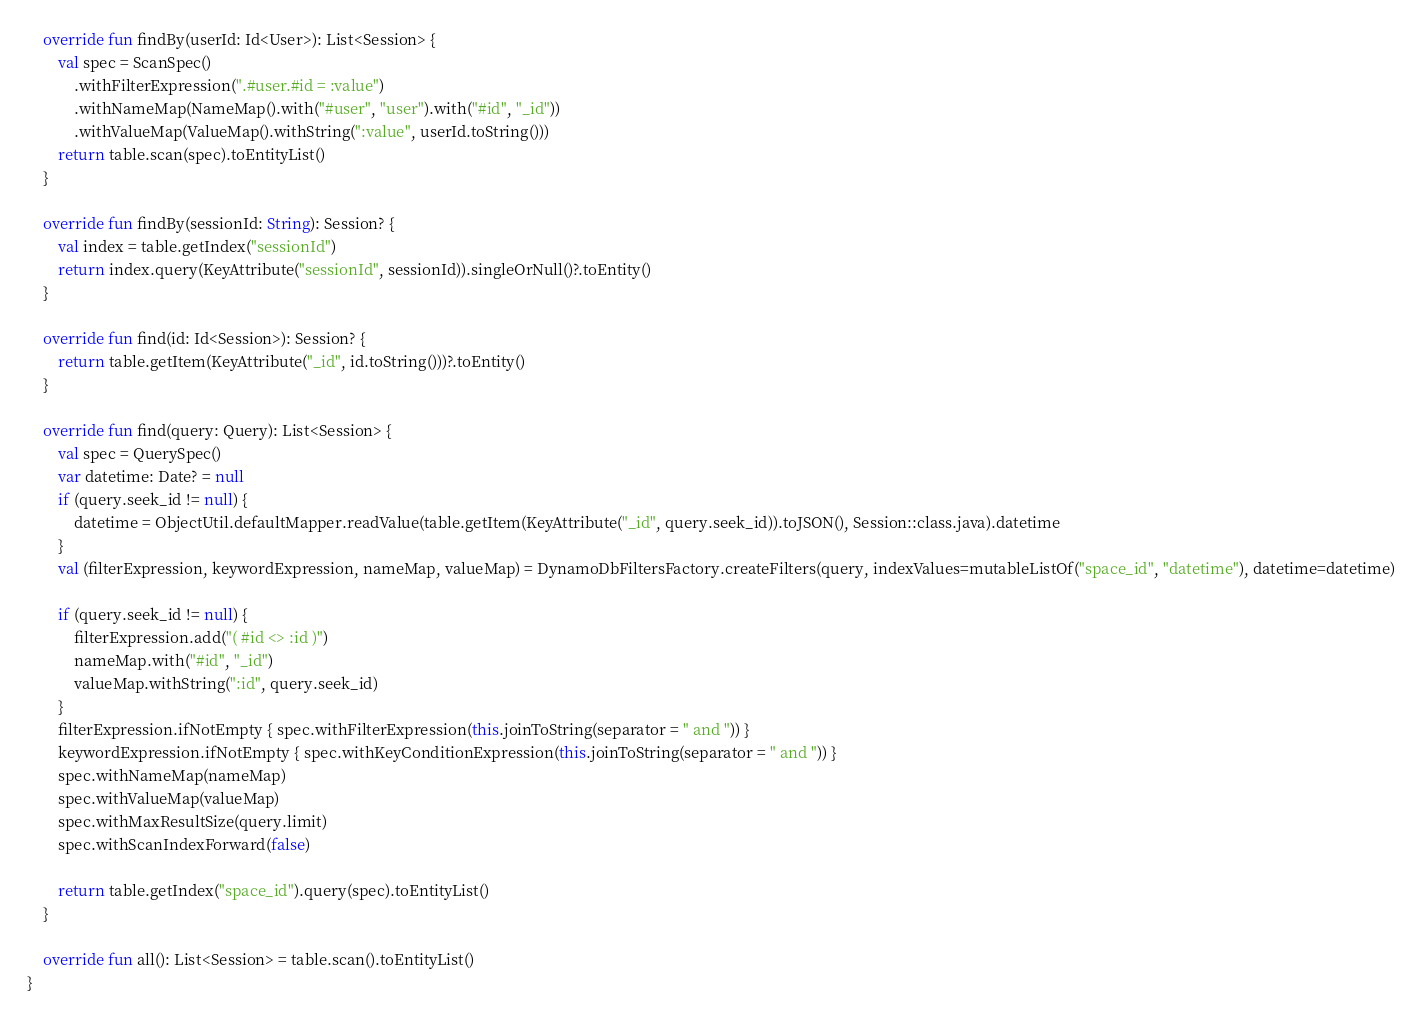Convert code to text. <code><loc_0><loc_0><loc_500><loc_500><_Kotlin_>
    override fun findBy(userId: Id<User>): List<Session> {
        val spec = ScanSpec()
            .withFilterExpression(".#user.#id = :value")
            .withNameMap(NameMap().with("#user", "user").with("#id", "_id"))
            .withValueMap(ValueMap().withString(":value", userId.toString()))
        return table.scan(spec).toEntityList()
    }

    override fun findBy(sessionId: String): Session? {
        val index = table.getIndex("sessionId")
        return index.query(KeyAttribute("sessionId", sessionId)).singleOrNull()?.toEntity()
    }

    override fun find(id: Id<Session>): Session? {
        return table.getItem(KeyAttribute("_id", id.toString()))?.toEntity()
    }

    override fun find(query: Query): List<Session> {
        val spec = QuerySpec()
        var datetime: Date? = null
        if (query.seek_id != null) {
            datetime = ObjectUtil.defaultMapper.readValue(table.getItem(KeyAttribute("_id", query.seek_id)).toJSON(), Session::class.java).datetime
        }
        val (filterExpression, keywordExpression, nameMap, valueMap) = DynamoDbFiltersFactory.createFilters(query, indexValues=mutableListOf("space_id", "datetime"), datetime=datetime)

        if (query.seek_id != null) {
            filterExpression.add("( #id <> :id )")
            nameMap.with("#id", "_id")
            valueMap.withString(":id", query.seek_id)
        }
        filterExpression.ifNotEmpty { spec.withFilterExpression(this.joinToString(separator = " and ")) }
        keywordExpression.ifNotEmpty { spec.withKeyConditionExpression(this.joinToString(separator = " and ")) }
        spec.withNameMap(nameMap)
        spec.withValueMap(valueMap)
        spec.withMaxResultSize(query.limit)
        spec.withScanIndexForward(false)

        return table.getIndex("space_id").query(spec).toEntityList()
    }

    override fun all(): List<Session> = table.scan().toEntityList()
}

</code> 